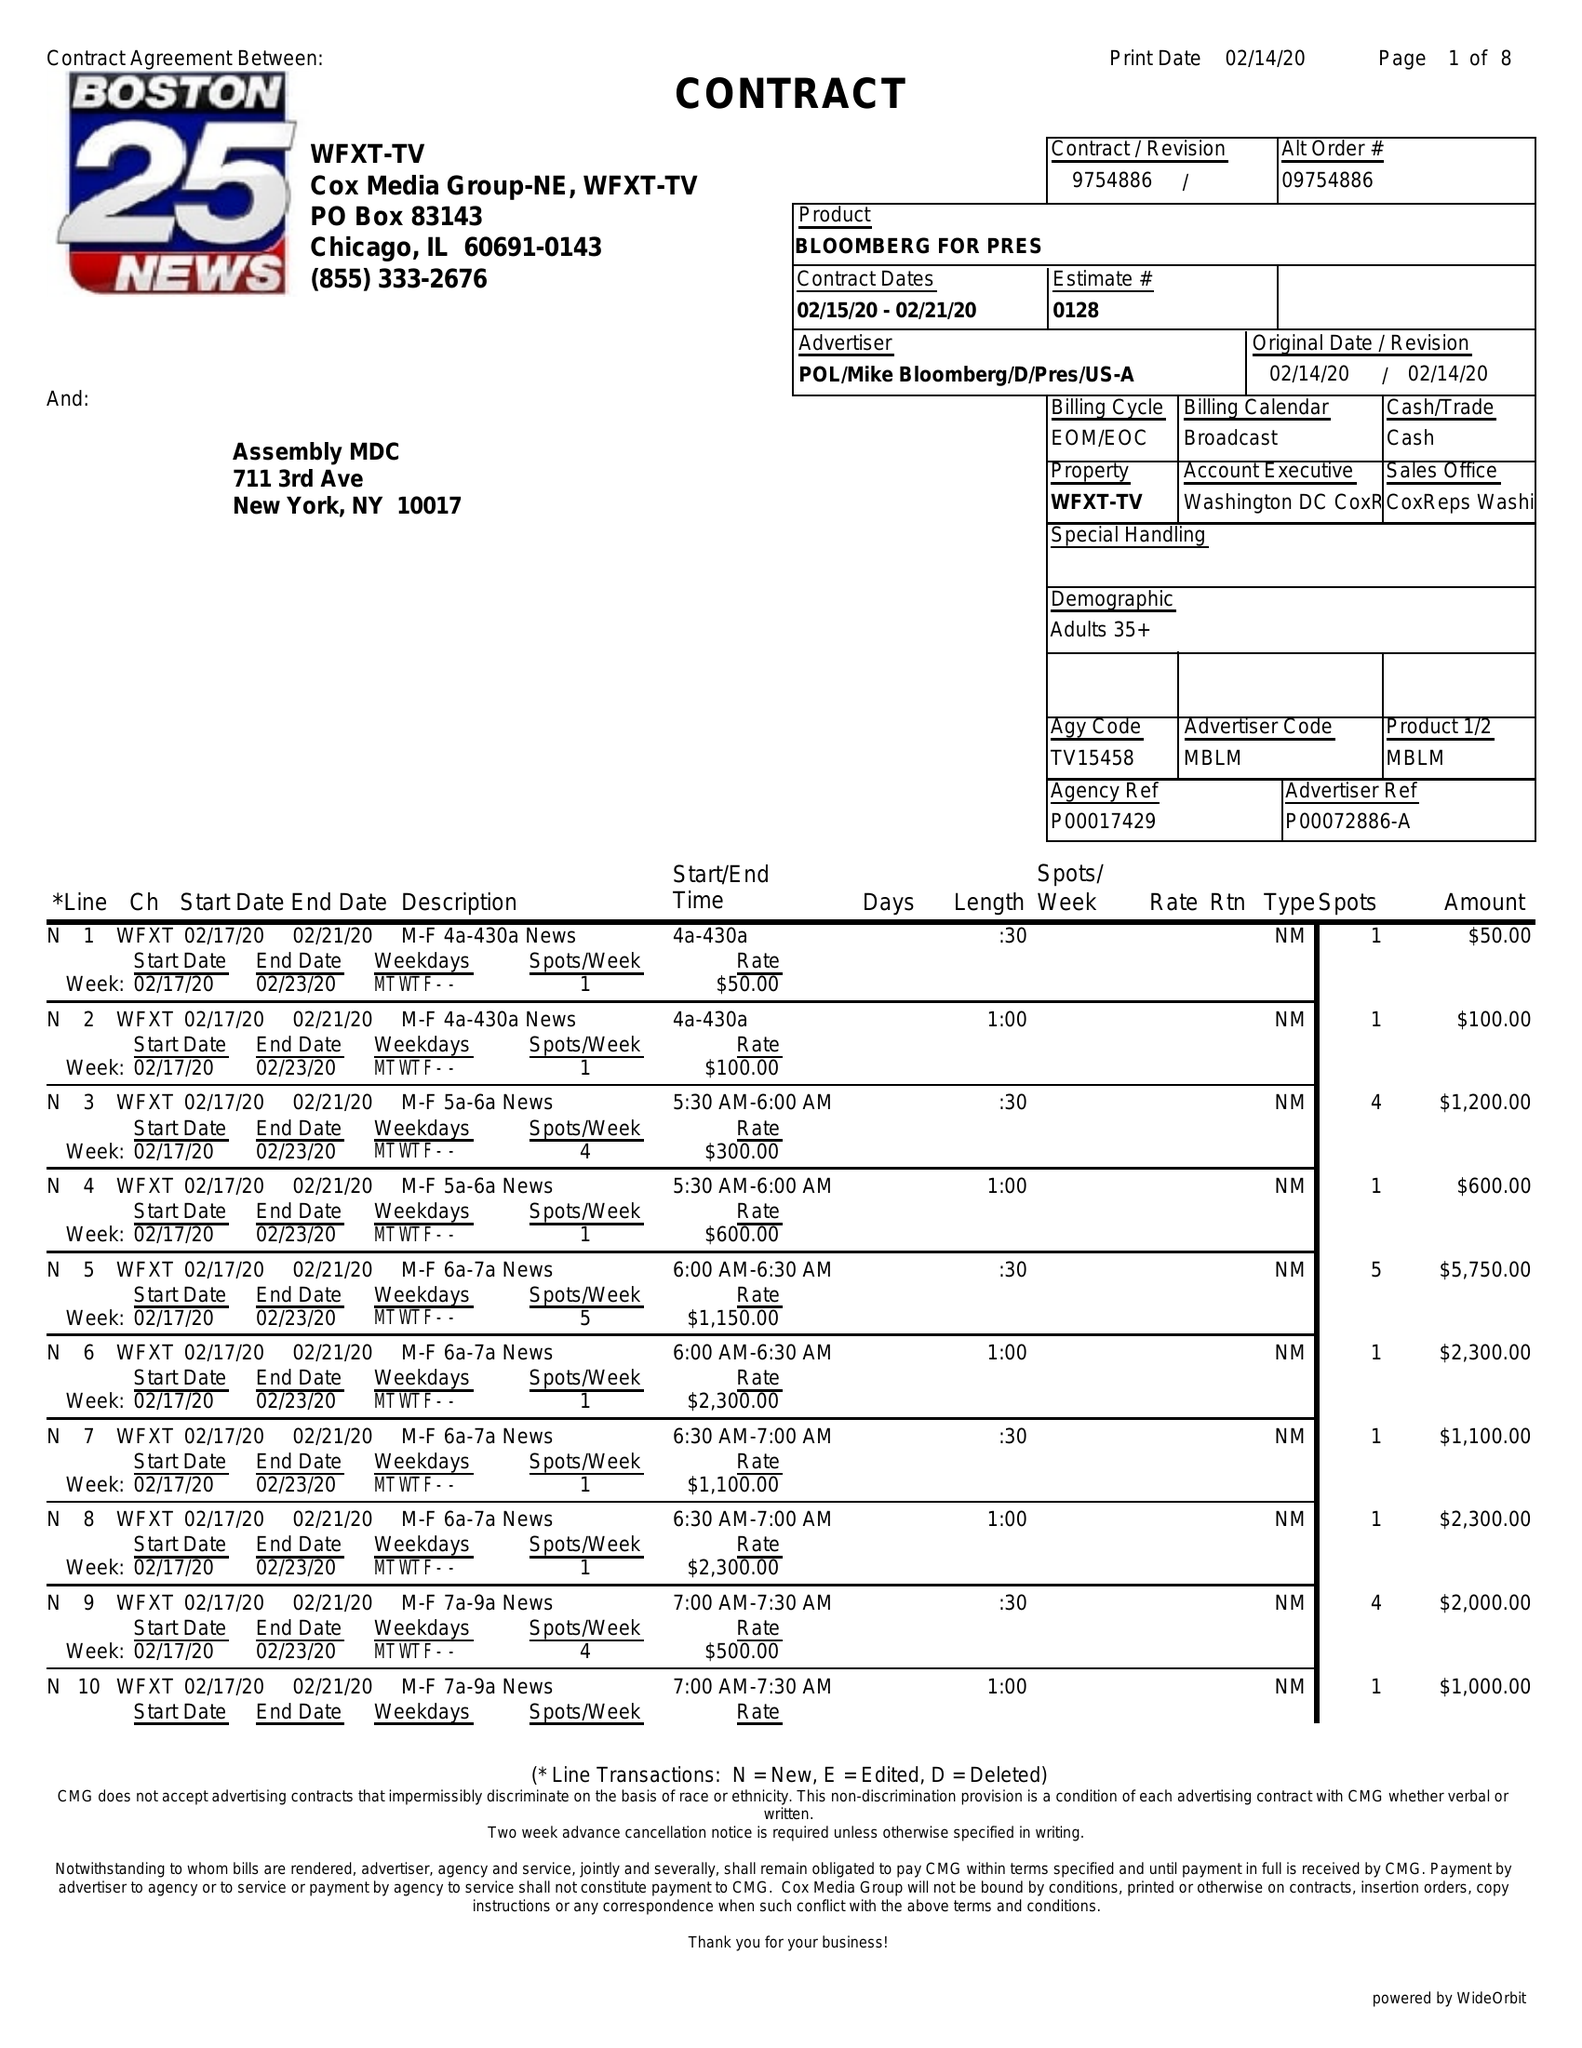What is the value for the advertiser?
Answer the question using a single word or phrase. BLOOMBERG FOR PRES 